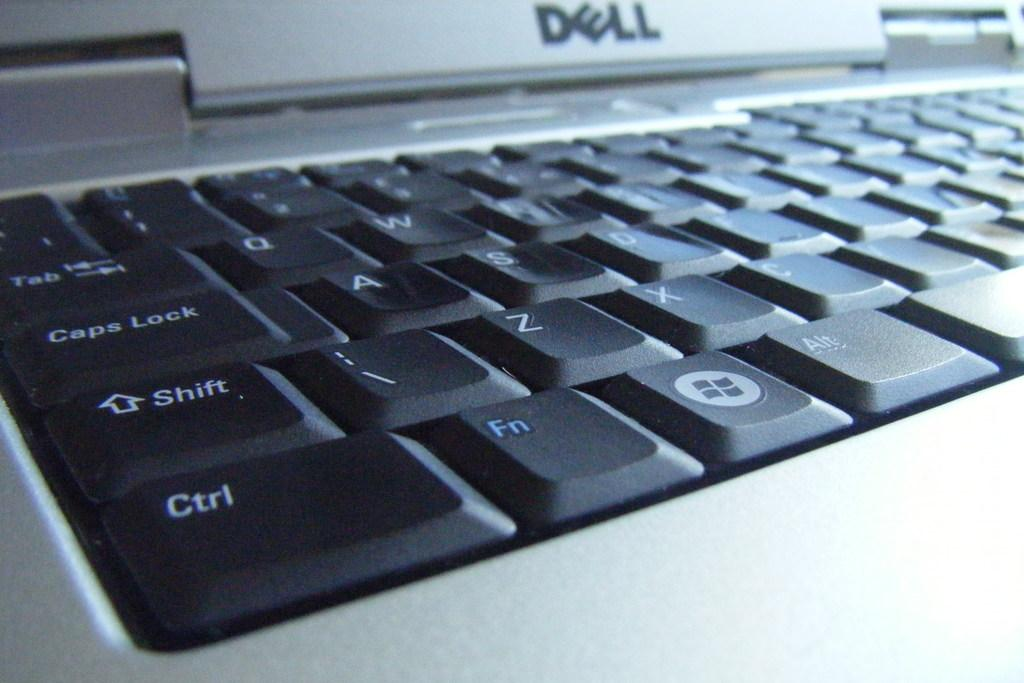<image>
Create a compact narrative representing the image presented. The Dell computer company manufactured the keyboard and computer.. 